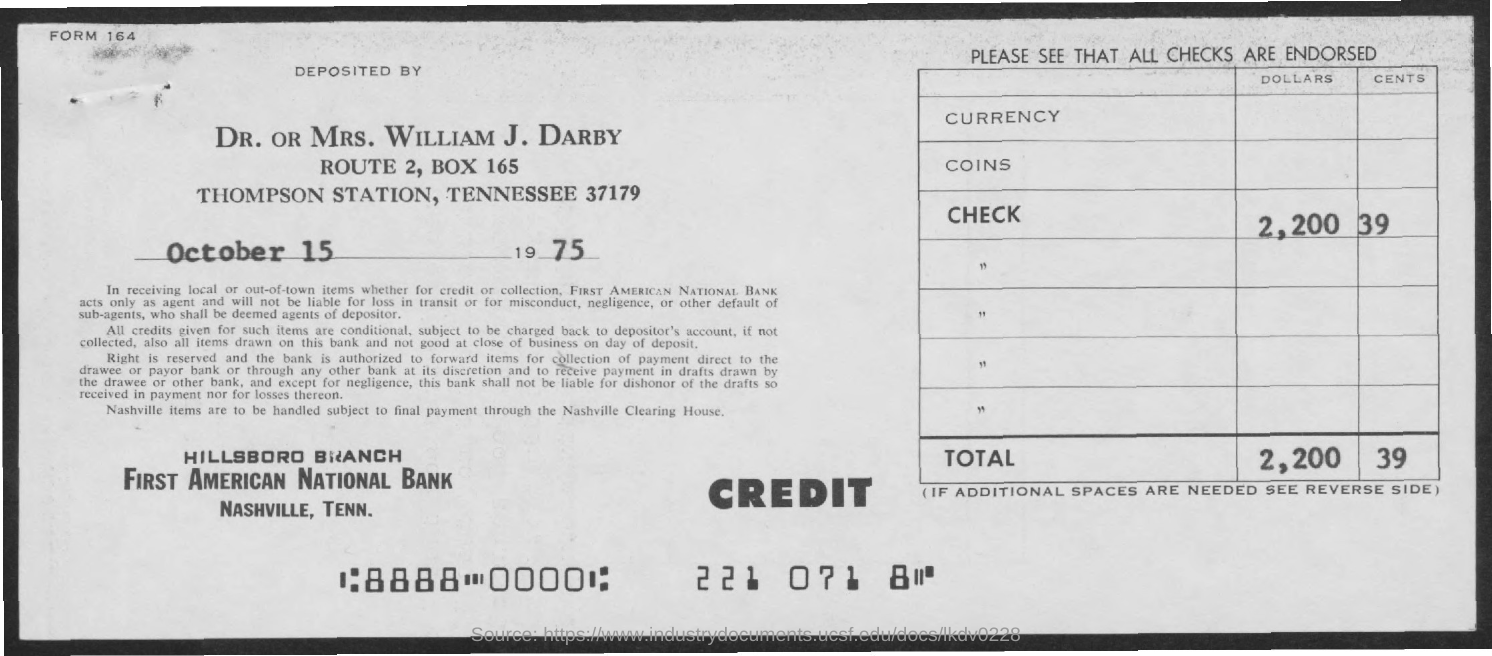Draw attention to some important aspects in this diagram. There are 39 cents credited. What is the form number mentioned at the top left corner? It is 164... This deposit has been made into First American National Bank. You have been credited with 2,200 dollars. 